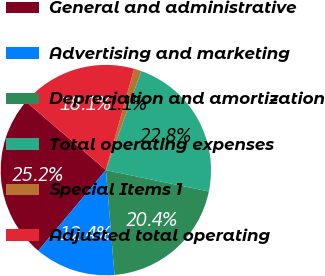<chart> <loc_0><loc_0><loc_500><loc_500><pie_chart><fcel>General and administrative<fcel>Advertising and marketing<fcel>Depreciation and amortization<fcel>Total operating expenses<fcel>Special Items 1<fcel>Adjusted total operating<nl><fcel>25.17%<fcel>12.42%<fcel>20.43%<fcel>22.8%<fcel>1.13%<fcel>18.06%<nl></chart> 